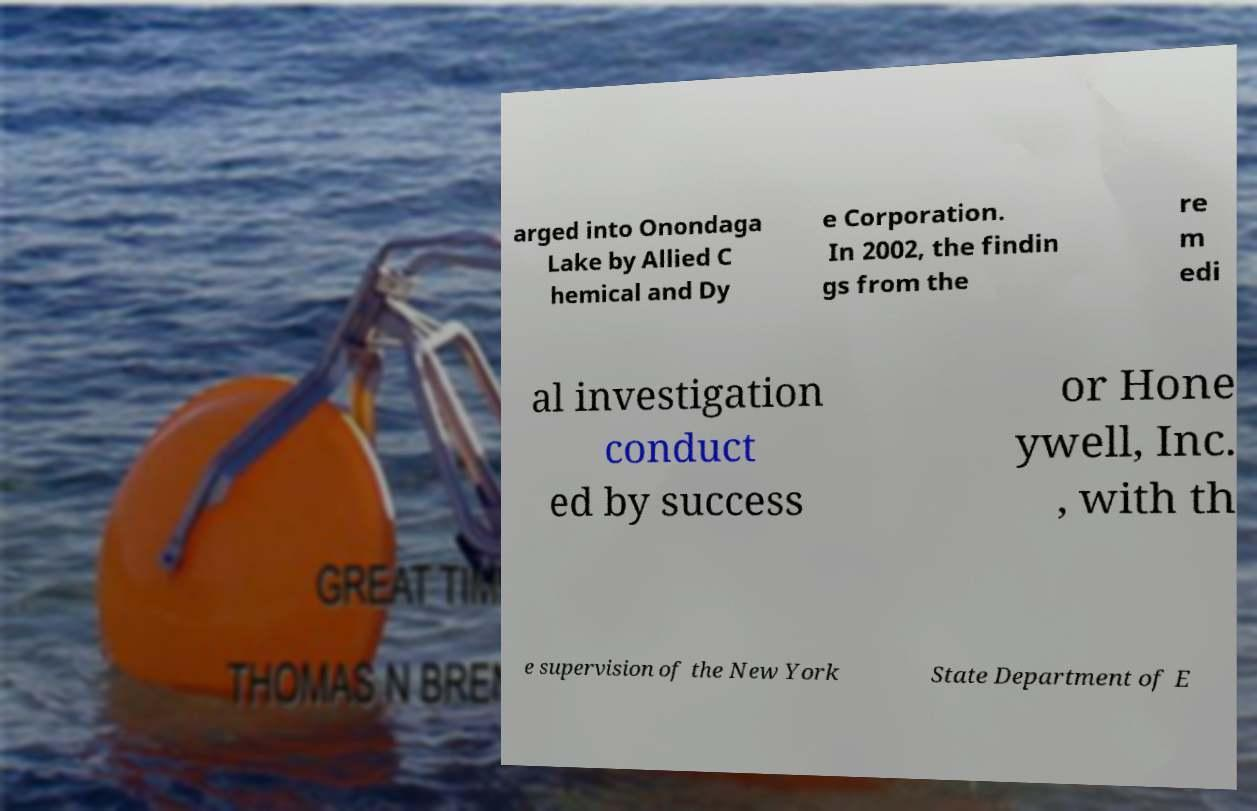Can you accurately transcribe the text from the provided image for me? arged into Onondaga Lake by Allied C hemical and Dy e Corporation. In 2002, the findin gs from the re m edi al investigation conduct ed by success or Hone ywell, Inc. , with th e supervision of the New York State Department of E 